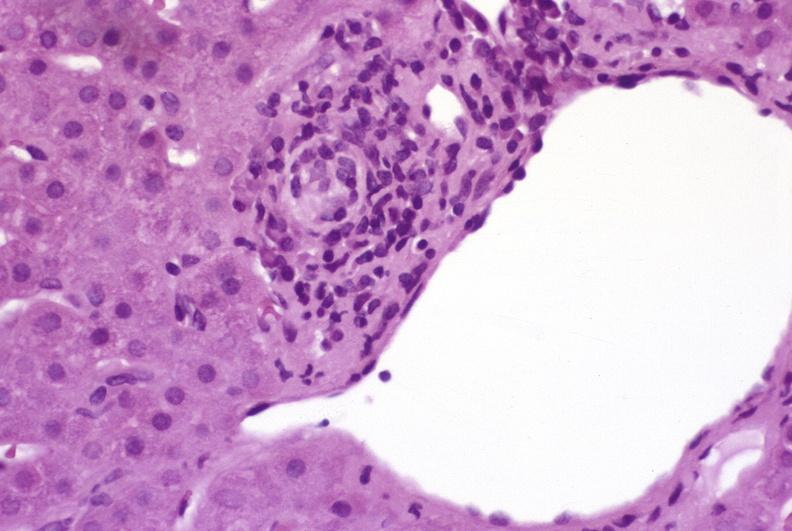what is present?
Answer the question using a single word or phrase. Liver 